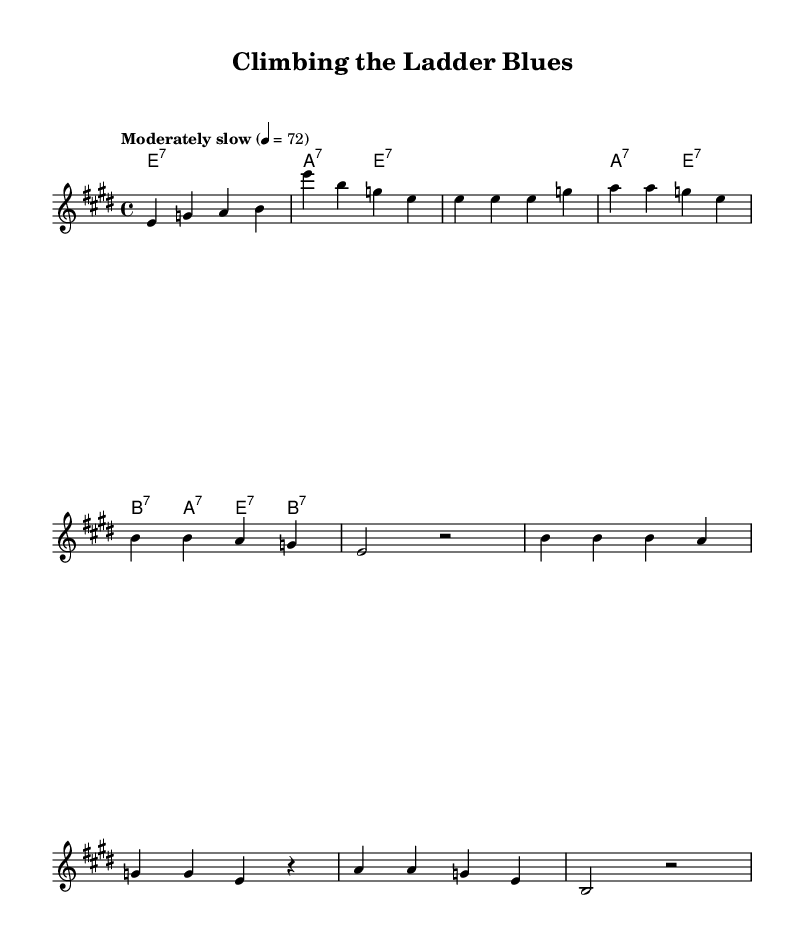What is the key signature of this music? The key signature is E major, which consists of four sharps (F#, C#, G#, and D#).
Answer: E major What is the time signature of this piece? The time signature is 4/4, indicating four beats per measure, with each quarter note receiving one beat.
Answer: 4/4 What is the tempo marking for this piece? The tempo marking in the score indicates "Moderately slow" with a metronome marking of 72 beats per minute.
Answer: Moderately slow How many measures are in the chorus section? The chorus section consists of four measures, as indicated by the grouping of notes in the score.
Answer: Four measures What type of chords are mainly used in the harmonies? The harmonies primarily use seventh chords, as denoted by the chord names such as e:7, a:7, and b:7 throughout the score.
Answer: Seventh chords What lyrical theme is presented in the first verse? The first verse focuses on personal ambition and determination to succeed, emphasizing the sentiment of climbing towards a goal.
Answer: Personal ambition 